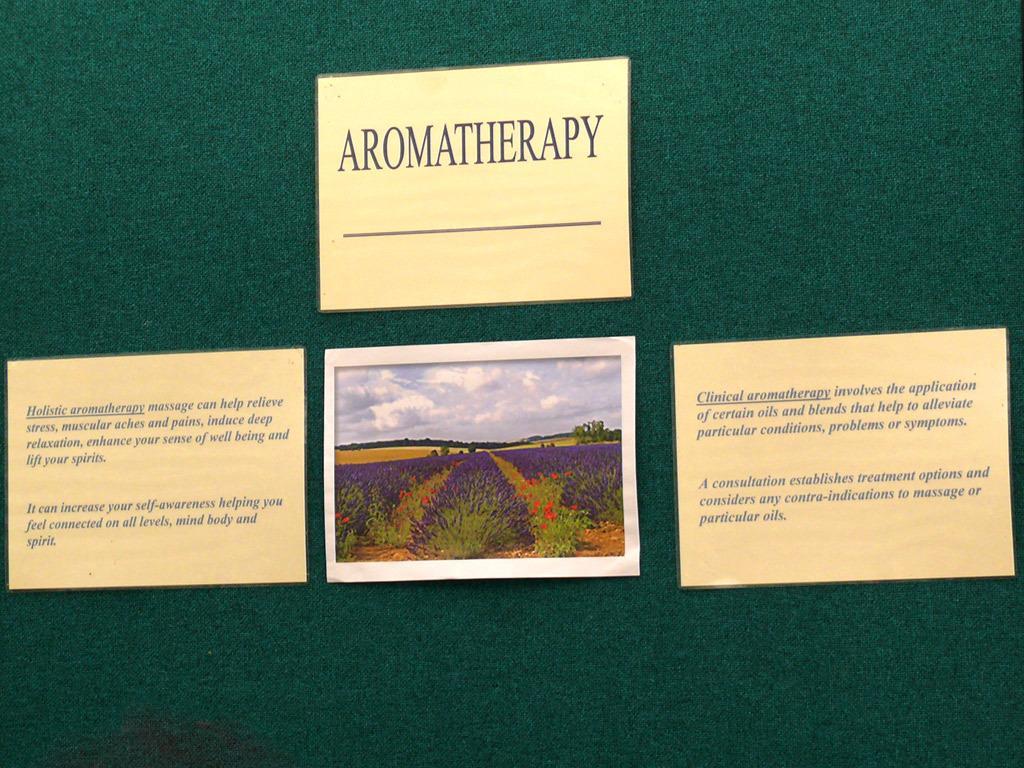Please provide a concise description of this image. In this image I can see the boards and frame to the green color surface. Three boards are in yellow color. And I can see the frame with plants. I can see some red and purple color flowers to the plants. And there is a sky in the front. 